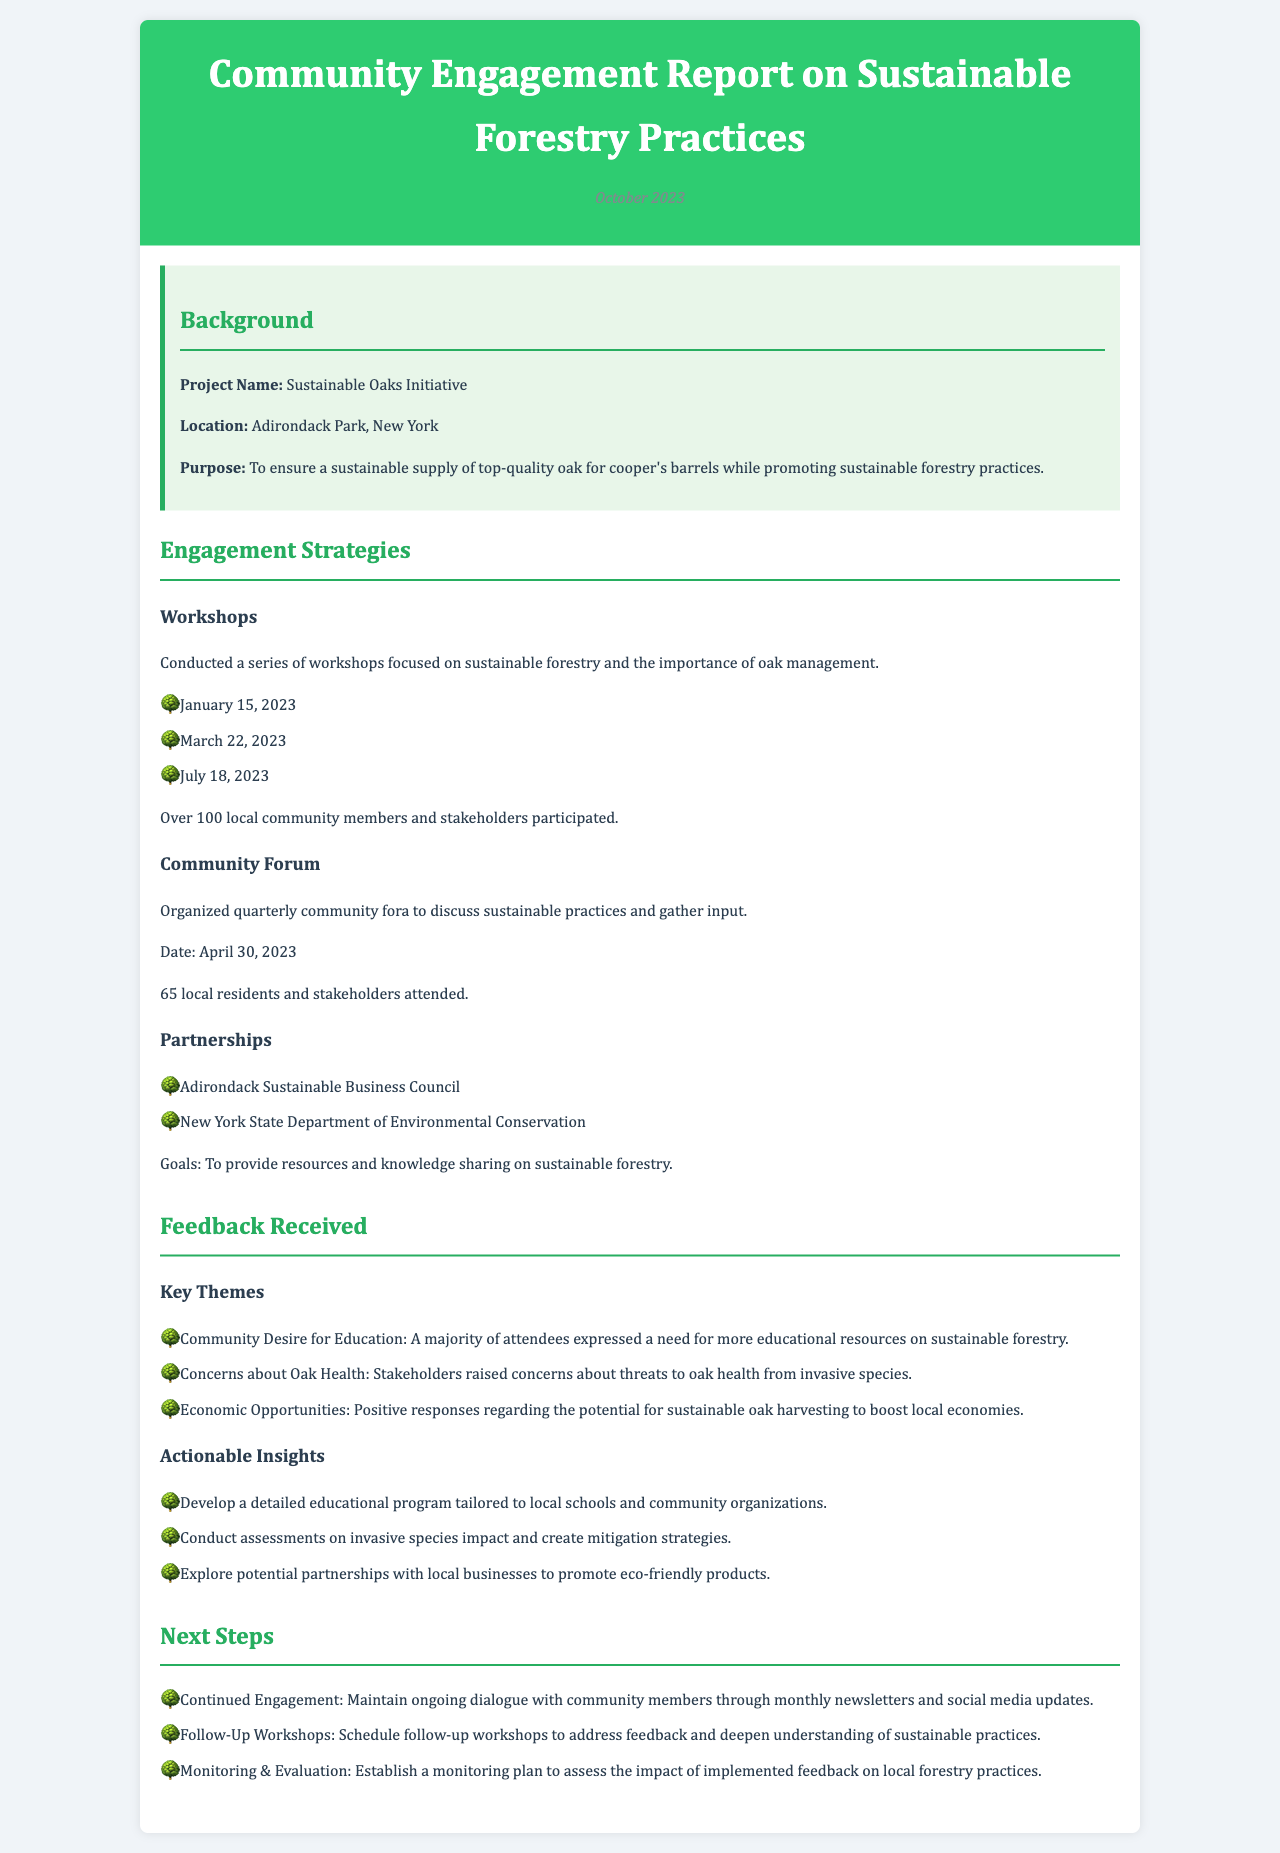What is the project name? The project name is specified in the background section of the report.
Answer: Sustainable Oaks Initiative Where is the project located? The location of the project is mentioned in the report's background section.
Answer: Adirondack Park, New York When was the community forum held? The date of the community forum is explicitly provided in the engagement strategies section.
Answer: April 30, 2023 How many participants attended the workshops? The number of participants in the workshops is provided in the engagement strategies section of the report.
Answer: Over 100 What is a key theme in the feedback received? The report lists key themes in the feedback section which highlights community concerns and desires.
Answer: Community Desire for Education What is one actionable insight from the feedback? The feedback section of the report outlines several actionable insights based on community input.
Answer: Develop a detailed educational program What is one of the next steps outlined in the report? The next steps section lists several actions to be taken after receiving feedback.
Answer: Continued Engagement Who is one of the partners in the initiative? The partnerships section lists organizations involved in the initiative.
Answer: Adirondack Sustainable Business Council 